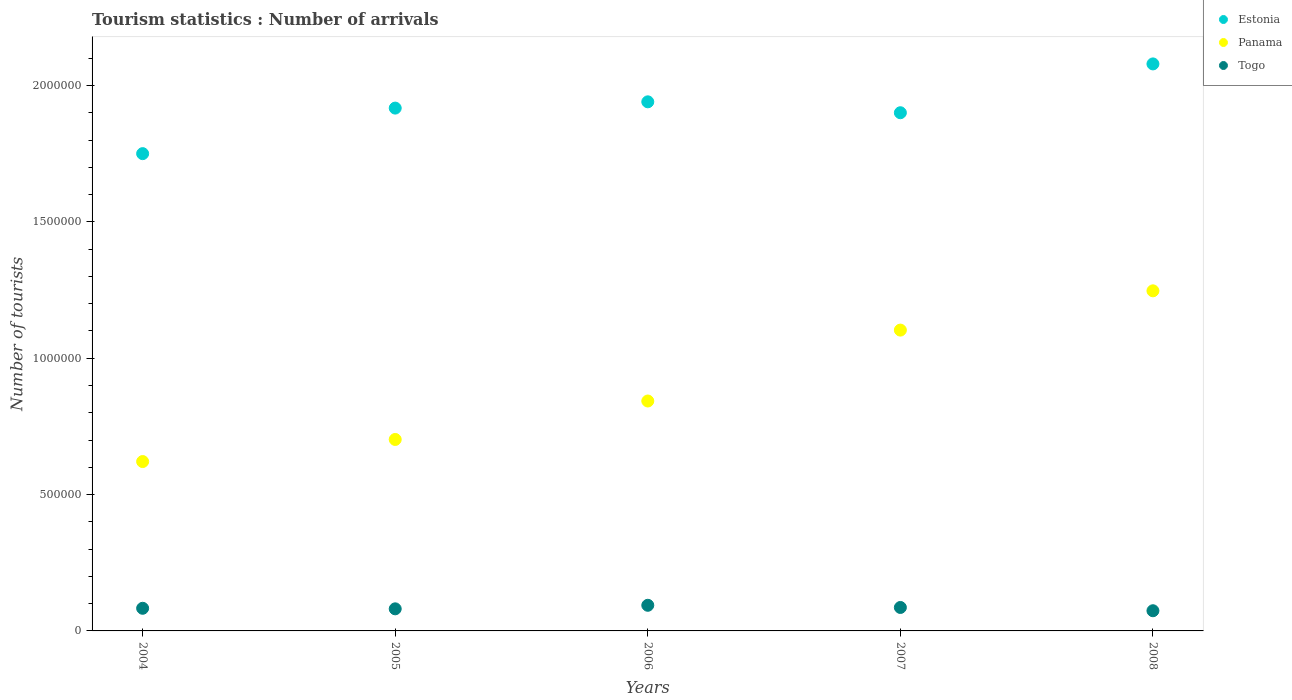How many different coloured dotlines are there?
Your answer should be very brief. 3. Is the number of dotlines equal to the number of legend labels?
Your answer should be very brief. Yes. What is the number of tourist arrivals in Panama in 2005?
Offer a terse response. 7.02e+05. Across all years, what is the maximum number of tourist arrivals in Togo?
Make the answer very short. 9.40e+04. Across all years, what is the minimum number of tourist arrivals in Panama?
Your response must be concise. 6.21e+05. In which year was the number of tourist arrivals in Estonia minimum?
Your answer should be compact. 2004. What is the total number of tourist arrivals in Estonia in the graph?
Your answer should be compact. 9.59e+06. What is the difference between the number of tourist arrivals in Estonia in 2004 and that in 2005?
Make the answer very short. -1.67e+05. What is the difference between the number of tourist arrivals in Togo in 2005 and the number of tourist arrivals in Estonia in 2007?
Keep it short and to the point. -1.82e+06. What is the average number of tourist arrivals in Estonia per year?
Your response must be concise. 1.92e+06. In the year 2007, what is the difference between the number of tourist arrivals in Panama and number of tourist arrivals in Estonia?
Ensure brevity in your answer.  -7.97e+05. What is the ratio of the number of tourist arrivals in Estonia in 2005 to that in 2007?
Your response must be concise. 1.01. What is the difference between the highest and the second highest number of tourist arrivals in Estonia?
Your answer should be very brief. 1.39e+05. What is the difference between the highest and the lowest number of tourist arrivals in Togo?
Ensure brevity in your answer.  2.00e+04. Is the number of tourist arrivals in Estonia strictly less than the number of tourist arrivals in Togo over the years?
Your response must be concise. No. How many dotlines are there?
Give a very brief answer. 3. How many years are there in the graph?
Provide a short and direct response. 5. What is the difference between two consecutive major ticks on the Y-axis?
Provide a short and direct response. 5.00e+05. Does the graph contain grids?
Offer a terse response. No. Where does the legend appear in the graph?
Offer a terse response. Top right. How are the legend labels stacked?
Your answer should be compact. Vertical. What is the title of the graph?
Offer a very short reply. Tourism statistics : Number of arrivals. Does "St. Vincent and the Grenadines" appear as one of the legend labels in the graph?
Your response must be concise. No. What is the label or title of the X-axis?
Offer a very short reply. Years. What is the label or title of the Y-axis?
Your answer should be very brief. Number of tourists. What is the Number of tourists in Estonia in 2004?
Provide a succinct answer. 1.75e+06. What is the Number of tourists in Panama in 2004?
Offer a terse response. 6.21e+05. What is the Number of tourists of Togo in 2004?
Ensure brevity in your answer.  8.30e+04. What is the Number of tourists of Estonia in 2005?
Your answer should be very brief. 1.92e+06. What is the Number of tourists in Panama in 2005?
Make the answer very short. 7.02e+05. What is the Number of tourists of Togo in 2005?
Offer a terse response. 8.10e+04. What is the Number of tourists in Estonia in 2006?
Your answer should be very brief. 1.94e+06. What is the Number of tourists in Panama in 2006?
Your answer should be compact. 8.43e+05. What is the Number of tourists in Togo in 2006?
Provide a succinct answer. 9.40e+04. What is the Number of tourists of Estonia in 2007?
Give a very brief answer. 1.90e+06. What is the Number of tourists of Panama in 2007?
Ensure brevity in your answer.  1.10e+06. What is the Number of tourists in Togo in 2007?
Your answer should be very brief. 8.60e+04. What is the Number of tourists of Estonia in 2008?
Keep it short and to the point. 2.08e+06. What is the Number of tourists of Panama in 2008?
Provide a succinct answer. 1.25e+06. What is the Number of tourists of Togo in 2008?
Keep it short and to the point. 7.40e+04. Across all years, what is the maximum Number of tourists in Estonia?
Your response must be concise. 2.08e+06. Across all years, what is the maximum Number of tourists of Panama?
Your answer should be very brief. 1.25e+06. Across all years, what is the maximum Number of tourists of Togo?
Give a very brief answer. 9.40e+04. Across all years, what is the minimum Number of tourists of Estonia?
Make the answer very short. 1.75e+06. Across all years, what is the minimum Number of tourists in Panama?
Provide a short and direct response. 6.21e+05. Across all years, what is the minimum Number of tourists of Togo?
Offer a very short reply. 7.40e+04. What is the total Number of tourists of Estonia in the graph?
Your answer should be compact. 9.59e+06. What is the total Number of tourists in Panama in the graph?
Offer a very short reply. 4.52e+06. What is the total Number of tourists of Togo in the graph?
Offer a terse response. 4.18e+05. What is the difference between the Number of tourists of Estonia in 2004 and that in 2005?
Offer a terse response. -1.67e+05. What is the difference between the Number of tourists of Panama in 2004 and that in 2005?
Keep it short and to the point. -8.10e+04. What is the difference between the Number of tourists in Togo in 2004 and that in 2005?
Provide a succinct answer. 2000. What is the difference between the Number of tourists in Panama in 2004 and that in 2006?
Provide a short and direct response. -2.22e+05. What is the difference between the Number of tourists of Togo in 2004 and that in 2006?
Your answer should be compact. -1.10e+04. What is the difference between the Number of tourists of Panama in 2004 and that in 2007?
Offer a very short reply. -4.82e+05. What is the difference between the Number of tourists in Togo in 2004 and that in 2007?
Your response must be concise. -3000. What is the difference between the Number of tourists of Estonia in 2004 and that in 2008?
Your response must be concise. -3.29e+05. What is the difference between the Number of tourists of Panama in 2004 and that in 2008?
Your response must be concise. -6.26e+05. What is the difference between the Number of tourists in Togo in 2004 and that in 2008?
Ensure brevity in your answer.  9000. What is the difference between the Number of tourists of Estonia in 2005 and that in 2006?
Your response must be concise. -2.30e+04. What is the difference between the Number of tourists of Panama in 2005 and that in 2006?
Provide a short and direct response. -1.41e+05. What is the difference between the Number of tourists in Togo in 2005 and that in 2006?
Make the answer very short. -1.30e+04. What is the difference between the Number of tourists in Estonia in 2005 and that in 2007?
Make the answer very short. 1.70e+04. What is the difference between the Number of tourists in Panama in 2005 and that in 2007?
Provide a short and direct response. -4.01e+05. What is the difference between the Number of tourists of Togo in 2005 and that in 2007?
Ensure brevity in your answer.  -5000. What is the difference between the Number of tourists of Estonia in 2005 and that in 2008?
Provide a succinct answer. -1.62e+05. What is the difference between the Number of tourists in Panama in 2005 and that in 2008?
Your response must be concise. -5.45e+05. What is the difference between the Number of tourists in Togo in 2005 and that in 2008?
Your answer should be compact. 7000. What is the difference between the Number of tourists of Estonia in 2006 and that in 2007?
Give a very brief answer. 4.00e+04. What is the difference between the Number of tourists of Togo in 2006 and that in 2007?
Give a very brief answer. 8000. What is the difference between the Number of tourists in Estonia in 2006 and that in 2008?
Make the answer very short. -1.39e+05. What is the difference between the Number of tourists of Panama in 2006 and that in 2008?
Keep it short and to the point. -4.04e+05. What is the difference between the Number of tourists in Togo in 2006 and that in 2008?
Ensure brevity in your answer.  2.00e+04. What is the difference between the Number of tourists of Estonia in 2007 and that in 2008?
Offer a very short reply. -1.79e+05. What is the difference between the Number of tourists in Panama in 2007 and that in 2008?
Keep it short and to the point. -1.44e+05. What is the difference between the Number of tourists in Togo in 2007 and that in 2008?
Make the answer very short. 1.20e+04. What is the difference between the Number of tourists in Estonia in 2004 and the Number of tourists in Panama in 2005?
Offer a very short reply. 1.05e+06. What is the difference between the Number of tourists in Estonia in 2004 and the Number of tourists in Togo in 2005?
Keep it short and to the point. 1.67e+06. What is the difference between the Number of tourists in Panama in 2004 and the Number of tourists in Togo in 2005?
Offer a very short reply. 5.40e+05. What is the difference between the Number of tourists of Estonia in 2004 and the Number of tourists of Panama in 2006?
Ensure brevity in your answer.  9.07e+05. What is the difference between the Number of tourists in Estonia in 2004 and the Number of tourists in Togo in 2006?
Your answer should be compact. 1.66e+06. What is the difference between the Number of tourists of Panama in 2004 and the Number of tourists of Togo in 2006?
Provide a short and direct response. 5.27e+05. What is the difference between the Number of tourists of Estonia in 2004 and the Number of tourists of Panama in 2007?
Offer a very short reply. 6.47e+05. What is the difference between the Number of tourists in Estonia in 2004 and the Number of tourists in Togo in 2007?
Keep it short and to the point. 1.66e+06. What is the difference between the Number of tourists of Panama in 2004 and the Number of tourists of Togo in 2007?
Give a very brief answer. 5.35e+05. What is the difference between the Number of tourists in Estonia in 2004 and the Number of tourists in Panama in 2008?
Give a very brief answer. 5.03e+05. What is the difference between the Number of tourists of Estonia in 2004 and the Number of tourists of Togo in 2008?
Your response must be concise. 1.68e+06. What is the difference between the Number of tourists of Panama in 2004 and the Number of tourists of Togo in 2008?
Make the answer very short. 5.47e+05. What is the difference between the Number of tourists of Estonia in 2005 and the Number of tourists of Panama in 2006?
Your answer should be compact. 1.07e+06. What is the difference between the Number of tourists of Estonia in 2005 and the Number of tourists of Togo in 2006?
Ensure brevity in your answer.  1.82e+06. What is the difference between the Number of tourists in Panama in 2005 and the Number of tourists in Togo in 2006?
Provide a short and direct response. 6.08e+05. What is the difference between the Number of tourists of Estonia in 2005 and the Number of tourists of Panama in 2007?
Provide a short and direct response. 8.14e+05. What is the difference between the Number of tourists in Estonia in 2005 and the Number of tourists in Togo in 2007?
Your answer should be compact. 1.83e+06. What is the difference between the Number of tourists of Panama in 2005 and the Number of tourists of Togo in 2007?
Provide a short and direct response. 6.16e+05. What is the difference between the Number of tourists in Estonia in 2005 and the Number of tourists in Panama in 2008?
Provide a short and direct response. 6.70e+05. What is the difference between the Number of tourists of Estonia in 2005 and the Number of tourists of Togo in 2008?
Your response must be concise. 1.84e+06. What is the difference between the Number of tourists of Panama in 2005 and the Number of tourists of Togo in 2008?
Keep it short and to the point. 6.28e+05. What is the difference between the Number of tourists in Estonia in 2006 and the Number of tourists in Panama in 2007?
Keep it short and to the point. 8.37e+05. What is the difference between the Number of tourists of Estonia in 2006 and the Number of tourists of Togo in 2007?
Offer a terse response. 1.85e+06. What is the difference between the Number of tourists of Panama in 2006 and the Number of tourists of Togo in 2007?
Your response must be concise. 7.57e+05. What is the difference between the Number of tourists in Estonia in 2006 and the Number of tourists in Panama in 2008?
Your answer should be compact. 6.93e+05. What is the difference between the Number of tourists in Estonia in 2006 and the Number of tourists in Togo in 2008?
Ensure brevity in your answer.  1.87e+06. What is the difference between the Number of tourists of Panama in 2006 and the Number of tourists of Togo in 2008?
Keep it short and to the point. 7.69e+05. What is the difference between the Number of tourists of Estonia in 2007 and the Number of tourists of Panama in 2008?
Offer a very short reply. 6.53e+05. What is the difference between the Number of tourists in Estonia in 2007 and the Number of tourists in Togo in 2008?
Offer a terse response. 1.83e+06. What is the difference between the Number of tourists of Panama in 2007 and the Number of tourists of Togo in 2008?
Your answer should be very brief. 1.03e+06. What is the average Number of tourists of Estonia per year?
Ensure brevity in your answer.  1.92e+06. What is the average Number of tourists of Panama per year?
Your response must be concise. 9.03e+05. What is the average Number of tourists of Togo per year?
Your response must be concise. 8.36e+04. In the year 2004, what is the difference between the Number of tourists in Estonia and Number of tourists in Panama?
Keep it short and to the point. 1.13e+06. In the year 2004, what is the difference between the Number of tourists in Estonia and Number of tourists in Togo?
Provide a short and direct response. 1.67e+06. In the year 2004, what is the difference between the Number of tourists of Panama and Number of tourists of Togo?
Give a very brief answer. 5.38e+05. In the year 2005, what is the difference between the Number of tourists of Estonia and Number of tourists of Panama?
Your answer should be very brief. 1.22e+06. In the year 2005, what is the difference between the Number of tourists in Estonia and Number of tourists in Togo?
Provide a short and direct response. 1.84e+06. In the year 2005, what is the difference between the Number of tourists of Panama and Number of tourists of Togo?
Your answer should be compact. 6.21e+05. In the year 2006, what is the difference between the Number of tourists in Estonia and Number of tourists in Panama?
Your answer should be compact. 1.10e+06. In the year 2006, what is the difference between the Number of tourists in Estonia and Number of tourists in Togo?
Your answer should be compact. 1.85e+06. In the year 2006, what is the difference between the Number of tourists in Panama and Number of tourists in Togo?
Offer a terse response. 7.49e+05. In the year 2007, what is the difference between the Number of tourists in Estonia and Number of tourists in Panama?
Your response must be concise. 7.97e+05. In the year 2007, what is the difference between the Number of tourists in Estonia and Number of tourists in Togo?
Your response must be concise. 1.81e+06. In the year 2007, what is the difference between the Number of tourists in Panama and Number of tourists in Togo?
Provide a short and direct response. 1.02e+06. In the year 2008, what is the difference between the Number of tourists in Estonia and Number of tourists in Panama?
Your response must be concise. 8.32e+05. In the year 2008, what is the difference between the Number of tourists in Estonia and Number of tourists in Togo?
Offer a very short reply. 2.00e+06. In the year 2008, what is the difference between the Number of tourists of Panama and Number of tourists of Togo?
Your answer should be very brief. 1.17e+06. What is the ratio of the Number of tourists of Estonia in 2004 to that in 2005?
Provide a succinct answer. 0.91. What is the ratio of the Number of tourists in Panama in 2004 to that in 2005?
Offer a very short reply. 0.88. What is the ratio of the Number of tourists in Togo in 2004 to that in 2005?
Provide a short and direct response. 1.02. What is the ratio of the Number of tourists in Estonia in 2004 to that in 2006?
Your answer should be very brief. 0.9. What is the ratio of the Number of tourists in Panama in 2004 to that in 2006?
Provide a succinct answer. 0.74. What is the ratio of the Number of tourists of Togo in 2004 to that in 2006?
Give a very brief answer. 0.88. What is the ratio of the Number of tourists of Estonia in 2004 to that in 2007?
Ensure brevity in your answer.  0.92. What is the ratio of the Number of tourists of Panama in 2004 to that in 2007?
Keep it short and to the point. 0.56. What is the ratio of the Number of tourists of Togo in 2004 to that in 2007?
Keep it short and to the point. 0.97. What is the ratio of the Number of tourists in Estonia in 2004 to that in 2008?
Ensure brevity in your answer.  0.84. What is the ratio of the Number of tourists in Panama in 2004 to that in 2008?
Your answer should be compact. 0.5. What is the ratio of the Number of tourists in Togo in 2004 to that in 2008?
Keep it short and to the point. 1.12. What is the ratio of the Number of tourists of Estonia in 2005 to that in 2006?
Make the answer very short. 0.99. What is the ratio of the Number of tourists in Panama in 2005 to that in 2006?
Your answer should be very brief. 0.83. What is the ratio of the Number of tourists in Togo in 2005 to that in 2006?
Your response must be concise. 0.86. What is the ratio of the Number of tourists in Estonia in 2005 to that in 2007?
Ensure brevity in your answer.  1.01. What is the ratio of the Number of tourists in Panama in 2005 to that in 2007?
Keep it short and to the point. 0.64. What is the ratio of the Number of tourists in Togo in 2005 to that in 2007?
Your answer should be compact. 0.94. What is the ratio of the Number of tourists of Estonia in 2005 to that in 2008?
Offer a very short reply. 0.92. What is the ratio of the Number of tourists in Panama in 2005 to that in 2008?
Offer a very short reply. 0.56. What is the ratio of the Number of tourists in Togo in 2005 to that in 2008?
Provide a succinct answer. 1.09. What is the ratio of the Number of tourists in Estonia in 2006 to that in 2007?
Give a very brief answer. 1.02. What is the ratio of the Number of tourists of Panama in 2006 to that in 2007?
Provide a short and direct response. 0.76. What is the ratio of the Number of tourists of Togo in 2006 to that in 2007?
Give a very brief answer. 1.09. What is the ratio of the Number of tourists of Estonia in 2006 to that in 2008?
Your response must be concise. 0.93. What is the ratio of the Number of tourists of Panama in 2006 to that in 2008?
Ensure brevity in your answer.  0.68. What is the ratio of the Number of tourists of Togo in 2006 to that in 2008?
Ensure brevity in your answer.  1.27. What is the ratio of the Number of tourists in Estonia in 2007 to that in 2008?
Provide a succinct answer. 0.91. What is the ratio of the Number of tourists in Panama in 2007 to that in 2008?
Ensure brevity in your answer.  0.88. What is the ratio of the Number of tourists of Togo in 2007 to that in 2008?
Give a very brief answer. 1.16. What is the difference between the highest and the second highest Number of tourists of Estonia?
Keep it short and to the point. 1.39e+05. What is the difference between the highest and the second highest Number of tourists of Panama?
Keep it short and to the point. 1.44e+05. What is the difference between the highest and the second highest Number of tourists in Togo?
Offer a very short reply. 8000. What is the difference between the highest and the lowest Number of tourists of Estonia?
Your answer should be very brief. 3.29e+05. What is the difference between the highest and the lowest Number of tourists in Panama?
Keep it short and to the point. 6.26e+05. 